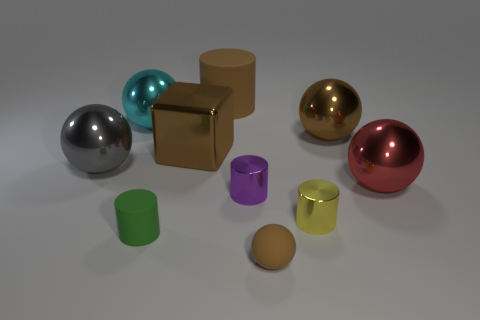Subtract all cyan spheres. How many spheres are left? 4 Subtract all big brown cylinders. How many cylinders are left? 3 Subtract all red cylinders. Subtract all cyan blocks. How many cylinders are left? 4 Subtract all cubes. How many objects are left? 9 Subtract 0 blue balls. How many objects are left? 10 Subtract all matte spheres. Subtract all red metal balls. How many objects are left? 8 Add 1 brown rubber cylinders. How many brown rubber cylinders are left? 2 Add 1 large brown cubes. How many large brown cubes exist? 2 